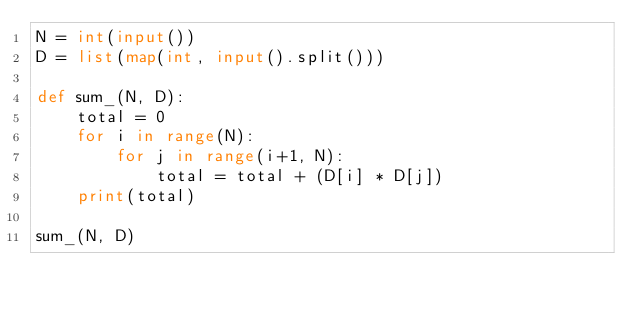Convert code to text. <code><loc_0><loc_0><loc_500><loc_500><_Python_>N = int(input())
D = list(map(int, input().split()))

def sum_(N, D):
    total = 0
    for i in range(N):
        for j in range(i+1, N):
            total = total + (D[i] * D[j])
    print(total)

sum_(N, D)</code> 